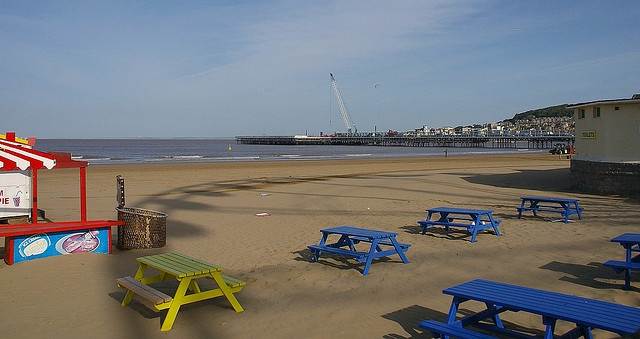Describe the objects in this image and their specific colors. I can see bench in gray, navy, black, and blue tones, bench in gray, olive, and black tones, bench in gray, blue, black, and navy tones, bench in gray, blue, and black tones, and bench in gray, black, navy, and blue tones in this image. 